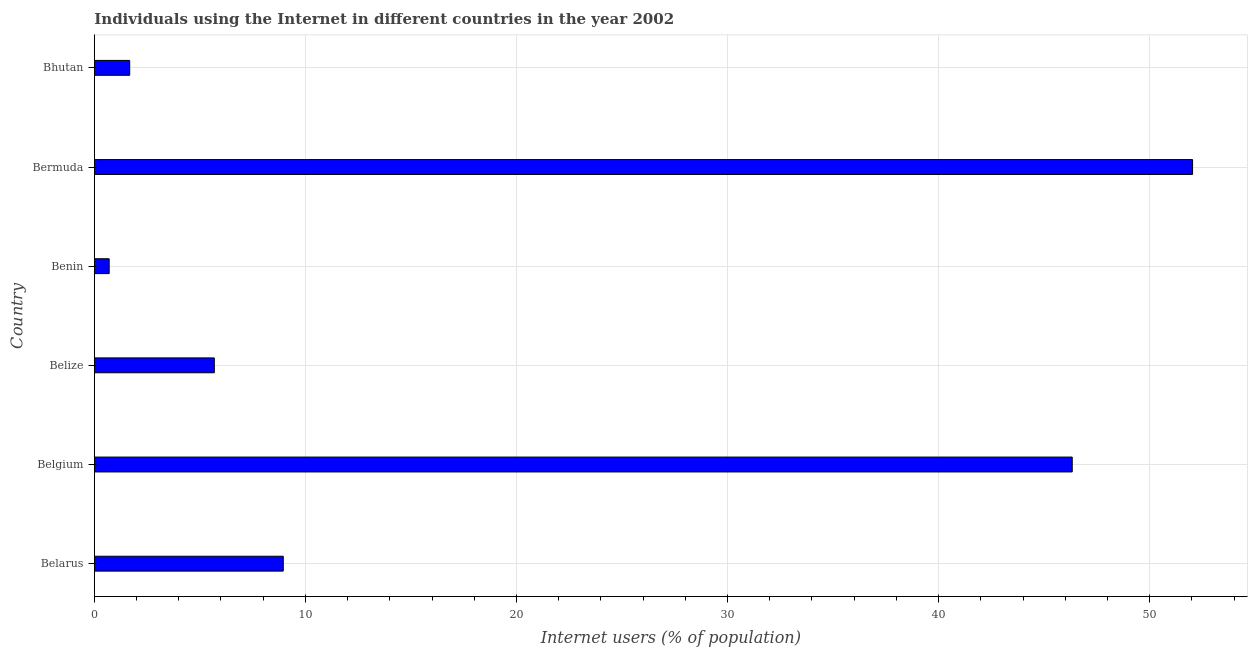Does the graph contain any zero values?
Ensure brevity in your answer.  No. Does the graph contain grids?
Provide a succinct answer. Yes. What is the title of the graph?
Provide a short and direct response. Individuals using the Internet in different countries in the year 2002. What is the label or title of the X-axis?
Provide a succinct answer. Internet users (% of population). What is the number of internet users in Benin?
Provide a short and direct response. 0.7. Across all countries, what is the maximum number of internet users?
Your response must be concise. 52.03. Across all countries, what is the minimum number of internet users?
Ensure brevity in your answer.  0.7. In which country was the number of internet users maximum?
Make the answer very short. Bermuda. In which country was the number of internet users minimum?
Your answer should be compact. Benin. What is the sum of the number of internet users?
Make the answer very short. 115.38. What is the difference between the number of internet users in Benin and Bhutan?
Offer a very short reply. -0.97. What is the average number of internet users per country?
Ensure brevity in your answer.  19.23. What is the median number of internet users?
Your answer should be very brief. 7.32. In how many countries, is the number of internet users greater than 4 %?
Ensure brevity in your answer.  4. What is the ratio of the number of internet users in Belgium to that in Benin?
Offer a terse response. 65.91. What is the difference between the highest and the second highest number of internet users?
Give a very brief answer. 5.7. What is the difference between the highest and the lowest number of internet users?
Give a very brief answer. 51.33. How many bars are there?
Make the answer very short. 6. Are all the bars in the graph horizontal?
Ensure brevity in your answer.  Yes. How many countries are there in the graph?
Keep it short and to the point. 6. What is the difference between two consecutive major ticks on the X-axis?
Provide a short and direct response. 10. Are the values on the major ticks of X-axis written in scientific E-notation?
Provide a short and direct response. No. What is the Internet users (% of population) in Belarus?
Ensure brevity in your answer.  8.95. What is the Internet users (% of population) of Belgium?
Your answer should be compact. 46.33. What is the Internet users (% of population) in Belize?
Offer a very short reply. 5.68. What is the Internet users (% of population) in Benin?
Offer a terse response. 0.7. What is the Internet users (% of population) of Bermuda?
Provide a succinct answer. 52.03. What is the Internet users (% of population) of Bhutan?
Provide a short and direct response. 1.68. What is the difference between the Internet users (% of population) in Belarus and Belgium?
Keep it short and to the point. -37.38. What is the difference between the Internet users (% of population) in Belarus and Belize?
Provide a succinct answer. 3.27. What is the difference between the Internet users (% of population) in Belarus and Benin?
Keep it short and to the point. 8.25. What is the difference between the Internet users (% of population) in Belarus and Bermuda?
Give a very brief answer. -43.08. What is the difference between the Internet users (% of population) in Belarus and Bhutan?
Provide a short and direct response. 7.28. What is the difference between the Internet users (% of population) in Belgium and Belize?
Your response must be concise. 40.65. What is the difference between the Internet users (% of population) in Belgium and Benin?
Provide a short and direct response. 45.63. What is the difference between the Internet users (% of population) in Belgium and Bermuda?
Your response must be concise. -5.7. What is the difference between the Internet users (% of population) in Belgium and Bhutan?
Offer a terse response. 44.65. What is the difference between the Internet users (% of population) in Belize and Benin?
Keep it short and to the point. 4.98. What is the difference between the Internet users (% of population) in Belize and Bermuda?
Keep it short and to the point. -46.35. What is the difference between the Internet users (% of population) in Belize and Bhutan?
Provide a short and direct response. 4.01. What is the difference between the Internet users (% of population) in Benin and Bermuda?
Offer a very short reply. -51.33. What is the difference between the Internet users (% of population) in Benin and Bhutan?
Offer a very short reply. -0.97. What is the difference between the Internet users (% of population) in Bermuda and Bhutan?
Keep it short and to the point. 50.36. What is the ratio of the Internet users (% of population) in Belarus to that in Belgium?
Provide a succinct answer. 0.19. What is the ratio of the Internet users (% of population) in Belarus to that in Belize?
Keep it short and to the point. 1.57. What is the ratio of the Internet users (% of population) in Belarus to that in Benin?
Give a very brief answer. 12.73. What is the ratio of the Internet users (% of population) in Belarus to that in Bermuda?
Your response must be concise. 0.17. What is the ratio of the Internet users (% of population) in Belarus to that in Bhutan?
Your response must be concise. 5.34. What is the ratio of the Internet users (% of population) in Belgium to that in Belize?
Provide a short and direct response. 8.15. What is the ratio of the Internet users (% of population) in Belgium to that in Benin?
Make the answer very short. 65.91. What is the ratio of the Internet users (% of population) in Belgium to that in Bermuda?
Provide a short and direct response. 0.89. What is the ratio of the Internet users (% of population) in Belgium to that in Bhutan?
Offer a terse response. 27.65. What is the ratio of the Internet users (% of population) in Belize to that in Benin?
Offer a very short reply. 8.09. What is the ratio of the Internet users (% of population) in Belize to that in Bermuda?
Give a very brief answer. 0.11. What is the ratio of the Internet users (% of population) in Belize to that in Bhutan?
Your response must be concise. 3.39. What is the ratio of the Internet users (% of population) in Benin to that in Bermuda?
Provide a short and direct response. 0.01. What is the ratio of the Internet users (% of population) in Benin to that in Bhutan?
Provide a short and direct response. 0.42. What is the ratio of the Internet users (% of population) in Bermuda to that in Bhutan?
Your answer should be compact. 31.05. 